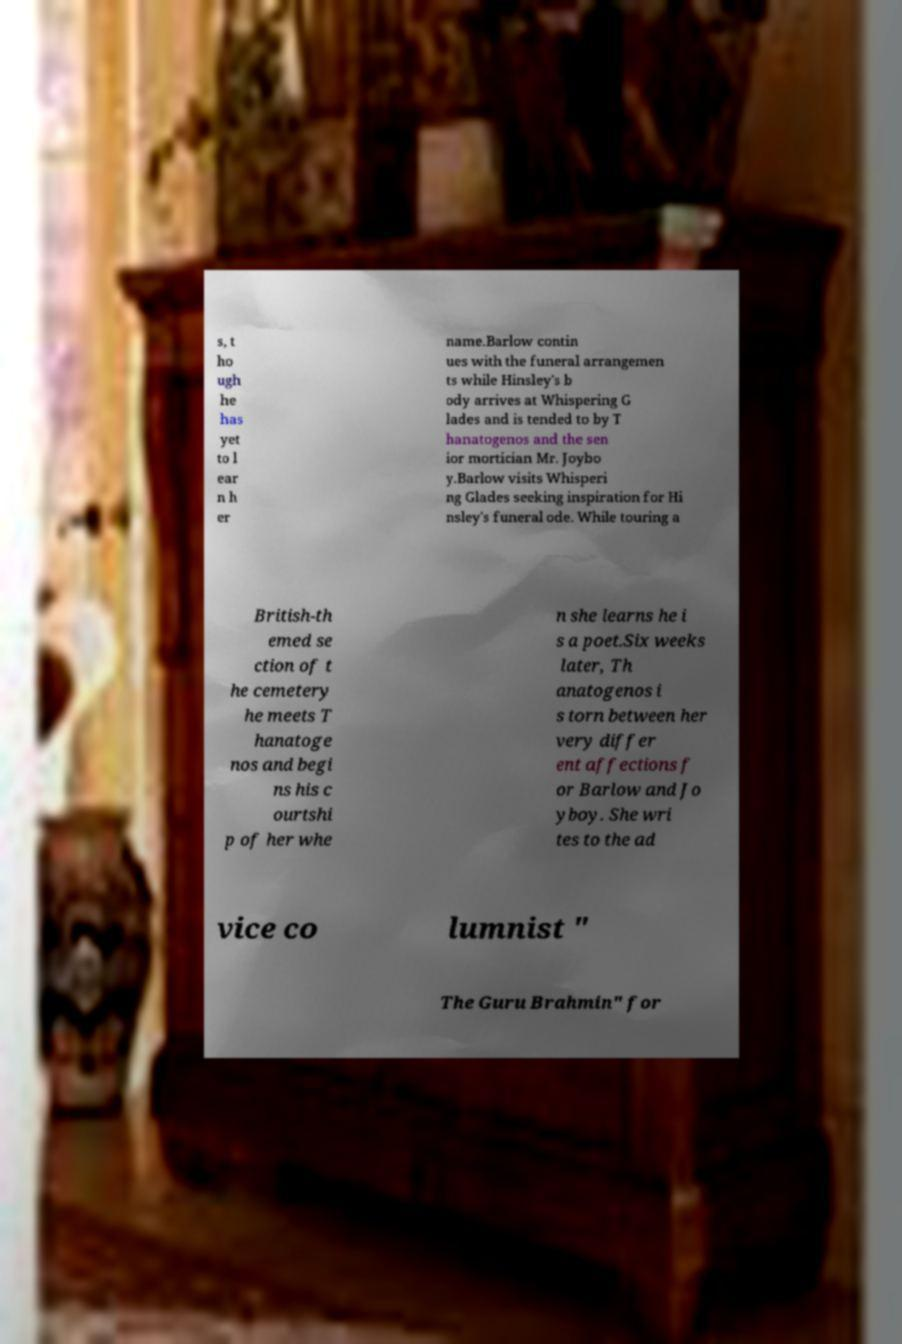Can you read and provide the text displayed in the image?This photo seems to have some interesting text. Can you extract and type it out for me? s, t ho ugh he has yet to l ear n h er name.Barlow contin ues with the funeral arrangemen ts while Hinsley's b ody arrives at Whispering G lades and is tended to by T hanatogenos and the sen ior mortician Mr. Joybo y.Barlow visits Whisperi ng Glades seeking inspiration for Hi nsley's funeral ode. While touring a British-th emed se ction of t he cemetery he meets T hanatoge nos and begi ns his c ourtshi p of her whe n she learns he i s a poet.Six weeks later, Th anatogenos i s torn between her very differ ent affections f or Barlow and Jo yboy. She wri tes to the ad vice co lumnist " The Guru Brahmin" for 